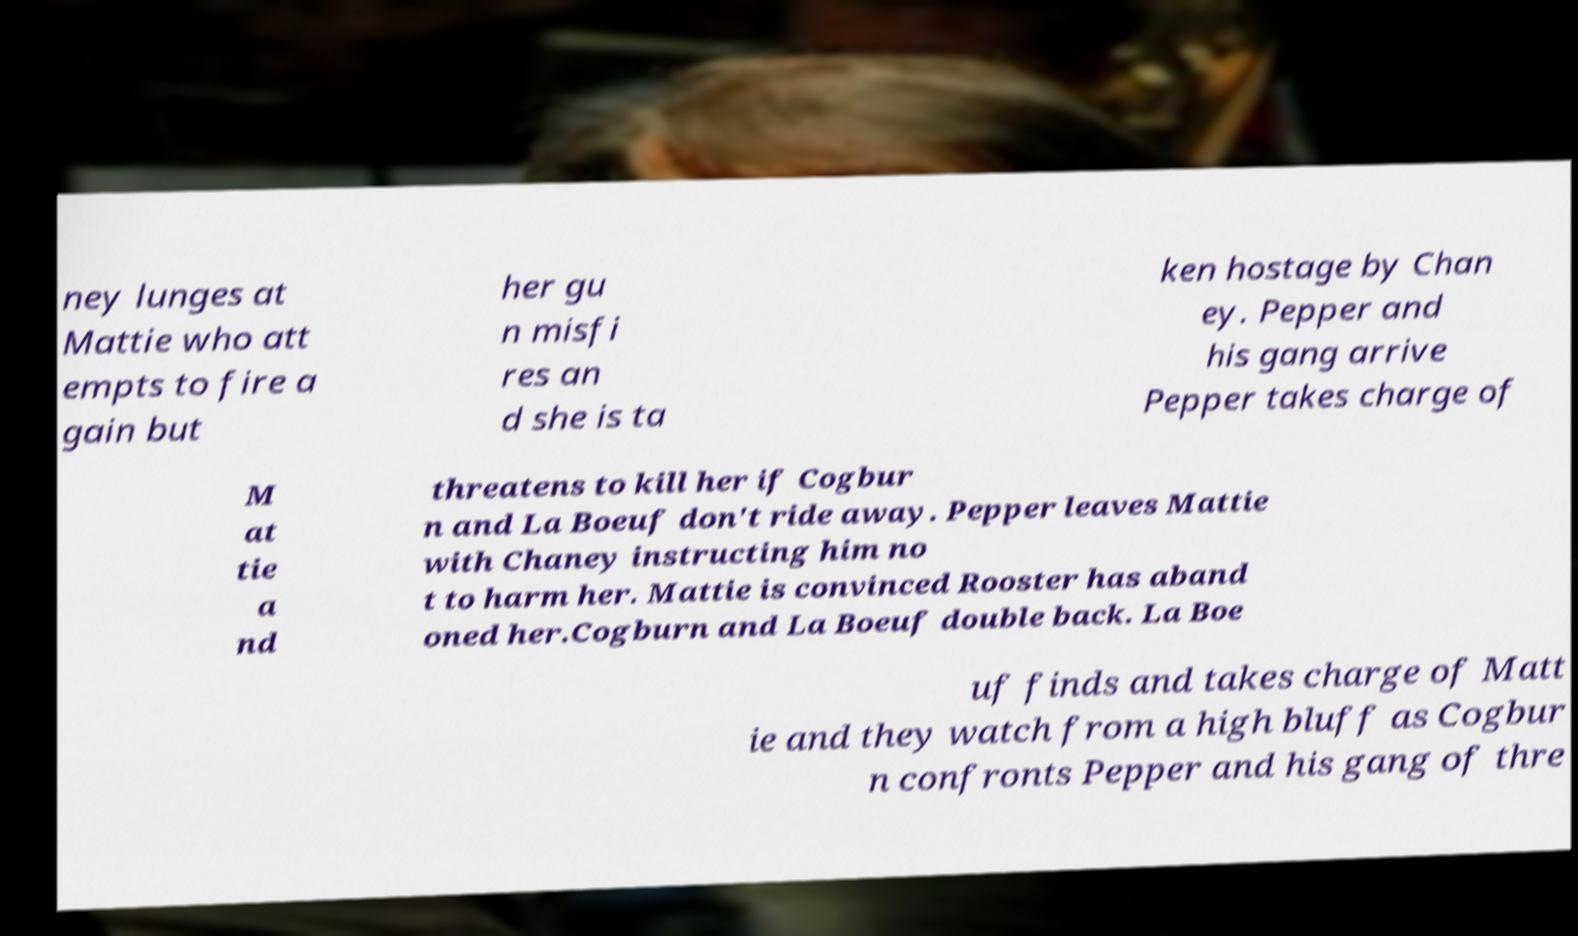Please read and relay the text visible in this image. What does it say? ney lunges at Mattie who att empts to fire a gain but her gu n misfi res an d she is ta ken hostage by Chan ey. Pepper and his gang arrive Pepper takes charge of M at tie a nd threatens to kill her if Cogbur n and La Boeuf don't ride away. Pepper leaves Mattie with Chaney instructing him no t to harm her. Mattie is convinced Rooster has aband oned her.Cogburn and La Boeuf double back. La Boe uf finds and takes charge of Matt ie and they watch from a high bluff as Cogbur n confronts Pepper and his gang of thre 